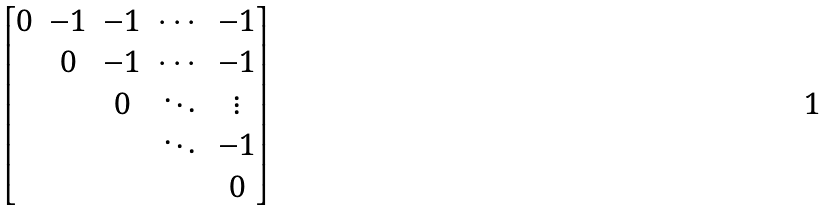Convert formula to latex. <formula><loc_0><loc_0><loc_500><loc_500>\begin{bmatrix} 0 & - 1 & - 1 & \cdots & - 1 \\ & 0 & - 1 & \cdots & - 1 \\ & & 0 & \ddots & \vdots \\ & & & \ddots & - 1 \\ & & & & 0 \end{bmatrix}</formula> 